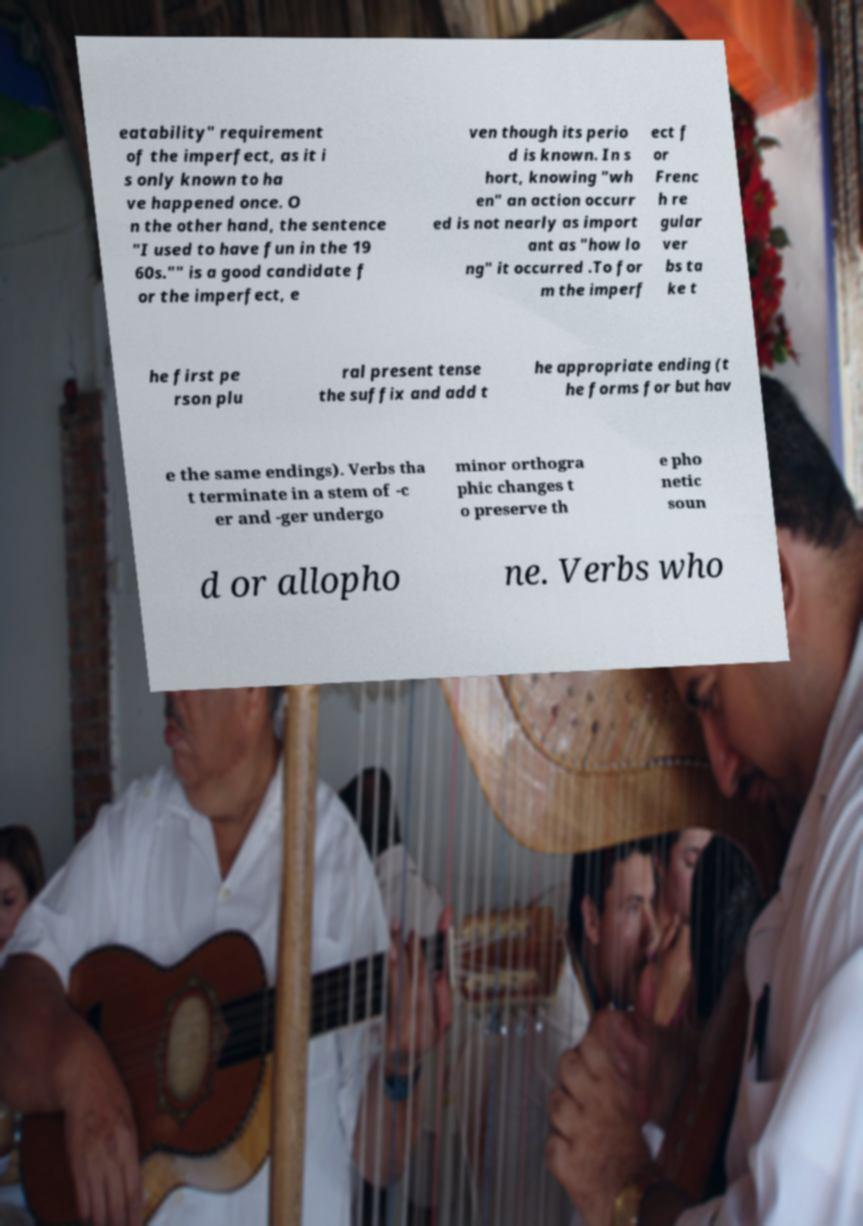Please read and relay the text visible in this image. What does it say? eatability" requirement of the imperfect, as it i s only known to ha ve happened once. O n the other hand, the sentence "I used to have fun in the 19 60s."" is a good candidate f or the imperfect, e ven though its perio d is known. In s hort, knowing "wh en" an action occurr ed is not nearly as import ant as "how lo ng" it occurred .To for m the imperf ect f or Frenc h re gular ver bs ta ke t he first pe rson plu ral present tense the suffix and add t he appropriate ending (t he forms for but hav e the same endings). Verbs tha t terminate in a stem of -c er and -ger undergo minor orthogra phic changes t o preserve th e pho netic soun d or allopho ne. Verbs who 